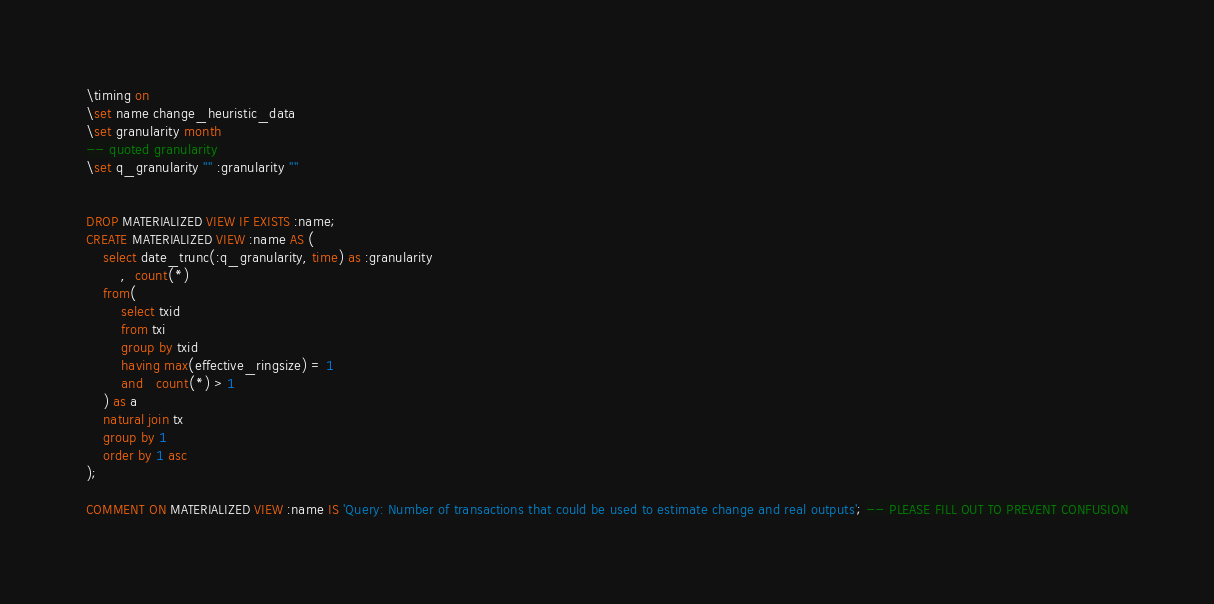<code> <loc_0><loc_0><loc_500><loc_500><_SQL_>\timing on
\set name change_heuristic_data
\set granularity month
-- quoted granularity
\set q_granularity '''' :granularity ''''


DROP MATERIALIZED VIEW IF EXISTS :name;
CREATE MATERIALIZED VIEW :name AS (
    select date_trunc(:q_granularity, time) as :granularity
        ,  count(*)
    from(
        select txid
        from txi
        group by txid
        having max(effective_ringsize) = 1
        and   count(*) > 1
    ) as a
    natural join tx
    group by 1
    order by 1 asc
);

COMMENT ON MATERIALIZED VIEW :name IS 'Query: Number of transactions that could be used to estimate change and real outputs'; -- PLEASE FILL OUT TO PREVENT CONFUSION</code> 